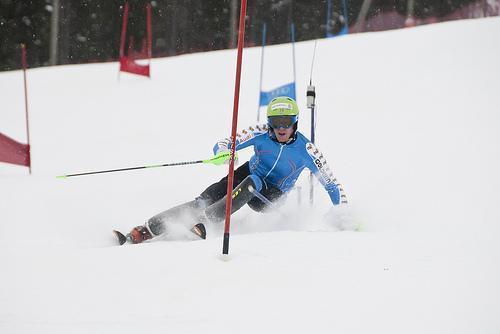How many people are seen?
Give a very brief answer. 1. 